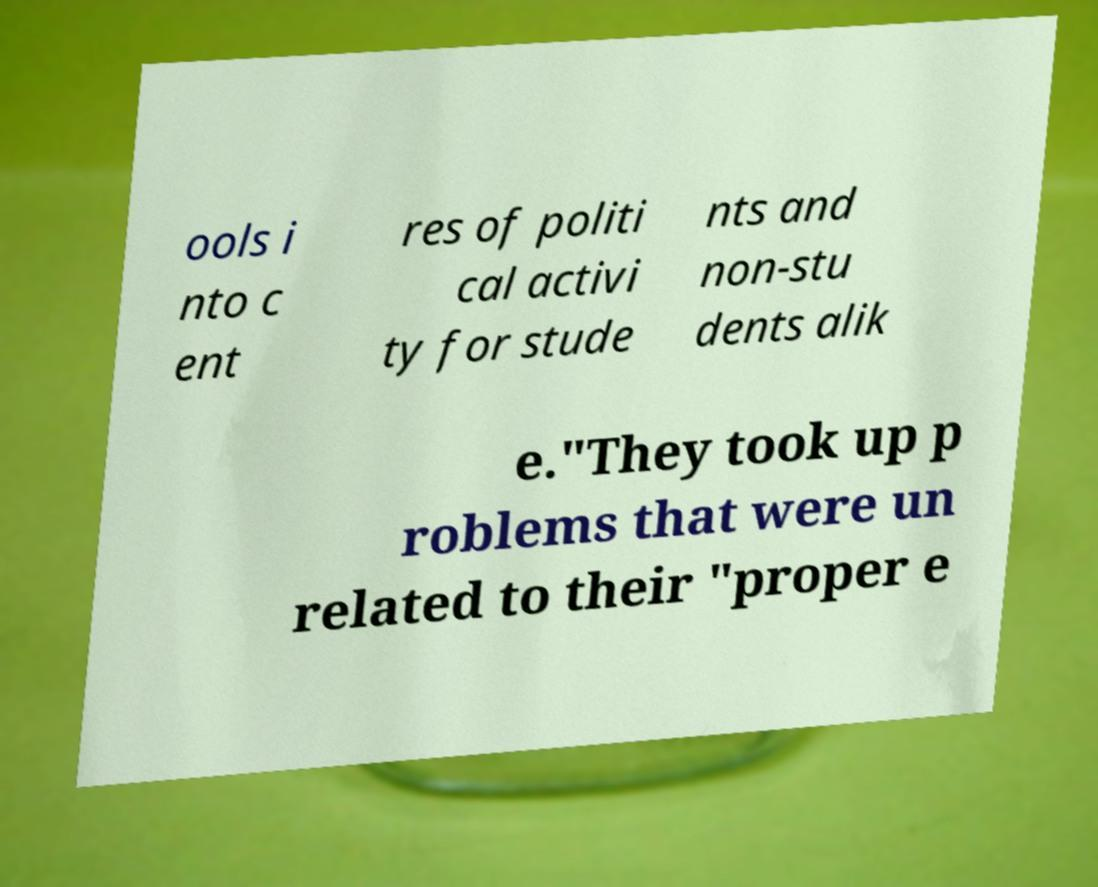Please identify and transcribe the text found in this image. ools i nto c ent res of politi cal activi ty for stude nts and non-stu dents alik e."They took up p roblems that were un related to their "proper e 